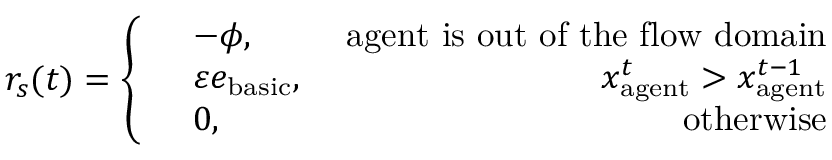Convert formula to latex. <formula><loc_0><loc_0><loc_500><loc_500>r _ { s } ( t ) = \left \{ \begin{array} { r l r } & { - \phi , \ } & { a g e n t i s o u t o f t h e f l o w d o m a i n } \\ & { \varepsilon e _ { b a s i c } , \ } & { x _ { a g e n t } ^ { t } > x _ { a g e n t } ^ { t - 1 } } \\ & { 0 , \ } & { o t h e r w i s e } \end{array}</formula> 